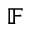<formula> <loc_0><loc_0><loc_500><loc_500>\mathbb { F }</formula> 